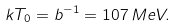Convert formula to latex. <formula><loc_0><loc_0><loc_500><loc_500>k T _ { 0 } = b ^ { - 1 } = 1 0 7 \, M e V .</formula> 